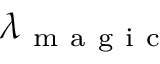Convert formula to latex. <formula><loc_0><loc_0><loc_500><loc_500>\lambda _ { m a g i c }</formula> 